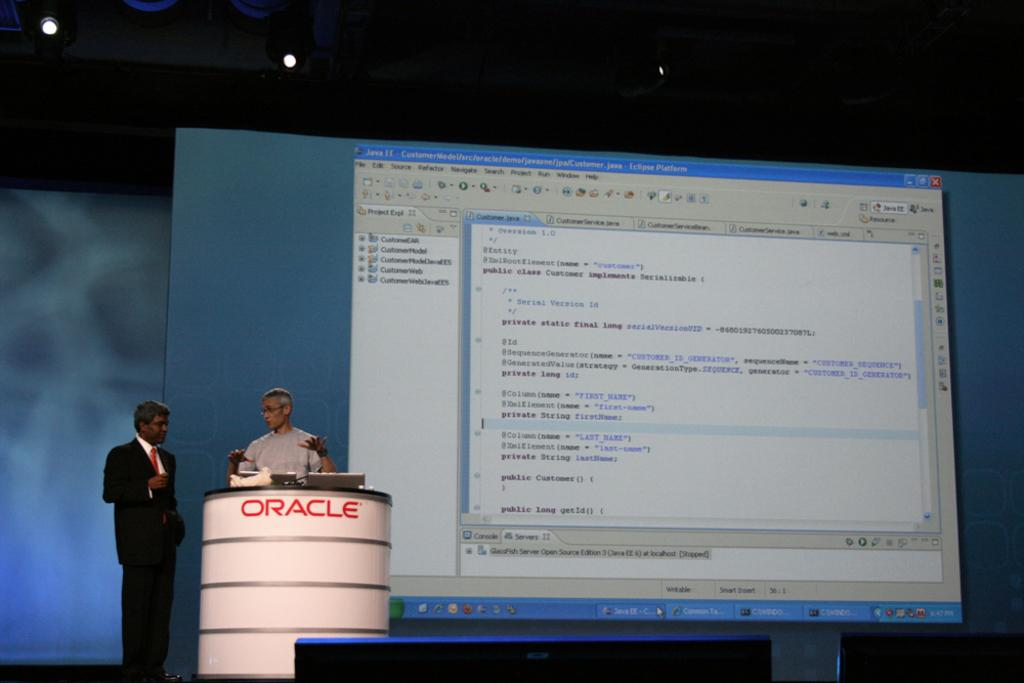<image>
Describe the image concisely. A presentation being given by a man at a podium labelled 'Oracle'. 